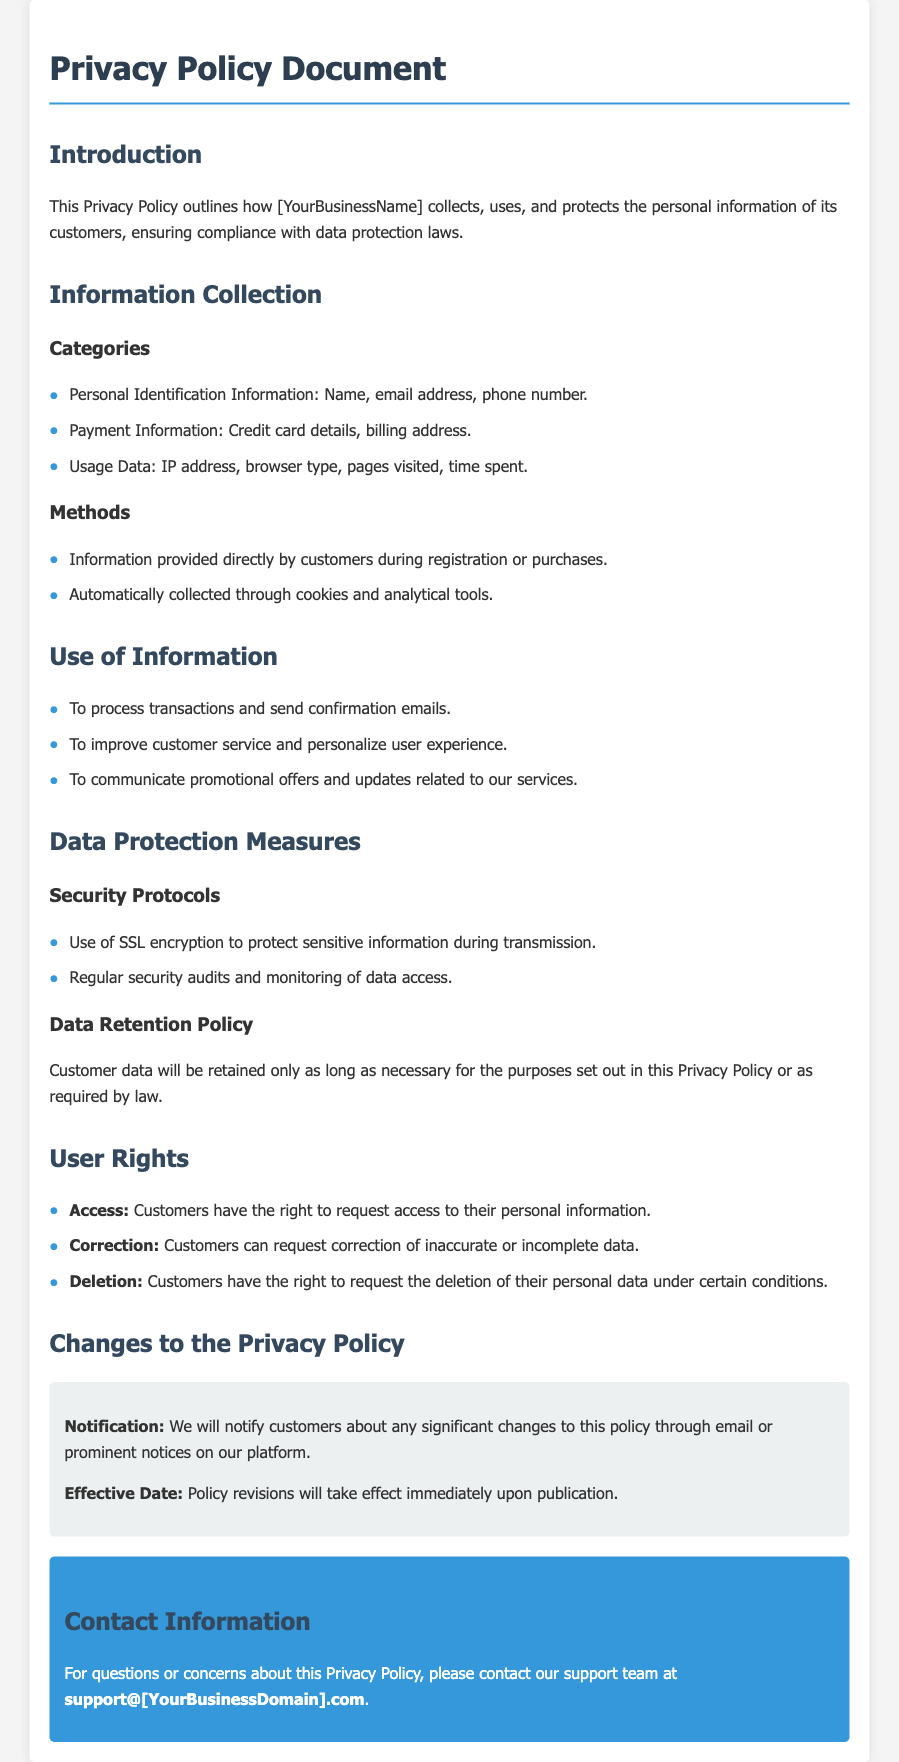What is the title of the document? The title is stated in the head section of the HTML document.
Answer: Privacy Policy - Your Business Name What types of personal identification information are collected? The section on Information Collection lists the types of information collected.
Answer: Name, email address, phone number What security protocol is mentioned for data protection? The Data Protection Measures section describes security protocols used.
Answer: SSL encryption What rights do customers have according to the document? The User Rights section outlines the rights of customers.
Answer: Access, Correction, Deletion How will customers be notified of significant changes to the policy? The Changes to the Privacy Policy section explains how customers will be informed.
Answer: Through email or prominent notices on our platform What is the purpose of collecting payment information? The Use of Information section briefly touches on the reasons for data collection.
Answer: To process transactions What is the effective date of policy revisions? The Changes to the Privacy Policy section indicates the timing of policy changes.
Answer: Immediately upon publication How can customers contact support for questions about the policy? The Contact Information section provides details on how to reach support.
Answer: support@[YourBusinessDomain].com 